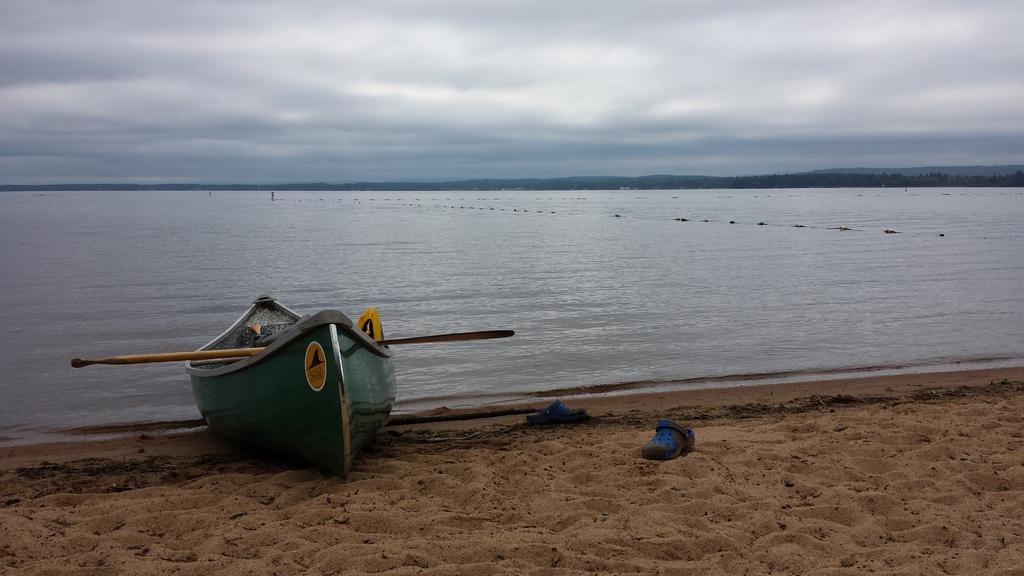Could you give a brief overview of what you see in this image? In the foreground of this image, there is sand, chapels and a boat. In the background, there is water, greenery and the sky. 